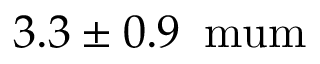Convert formula to latex. <formula><loc_0><loc_0><loc_500><loc_500>3 . 3 \pm 0 . 9 \, { \ m u m }</formula> 